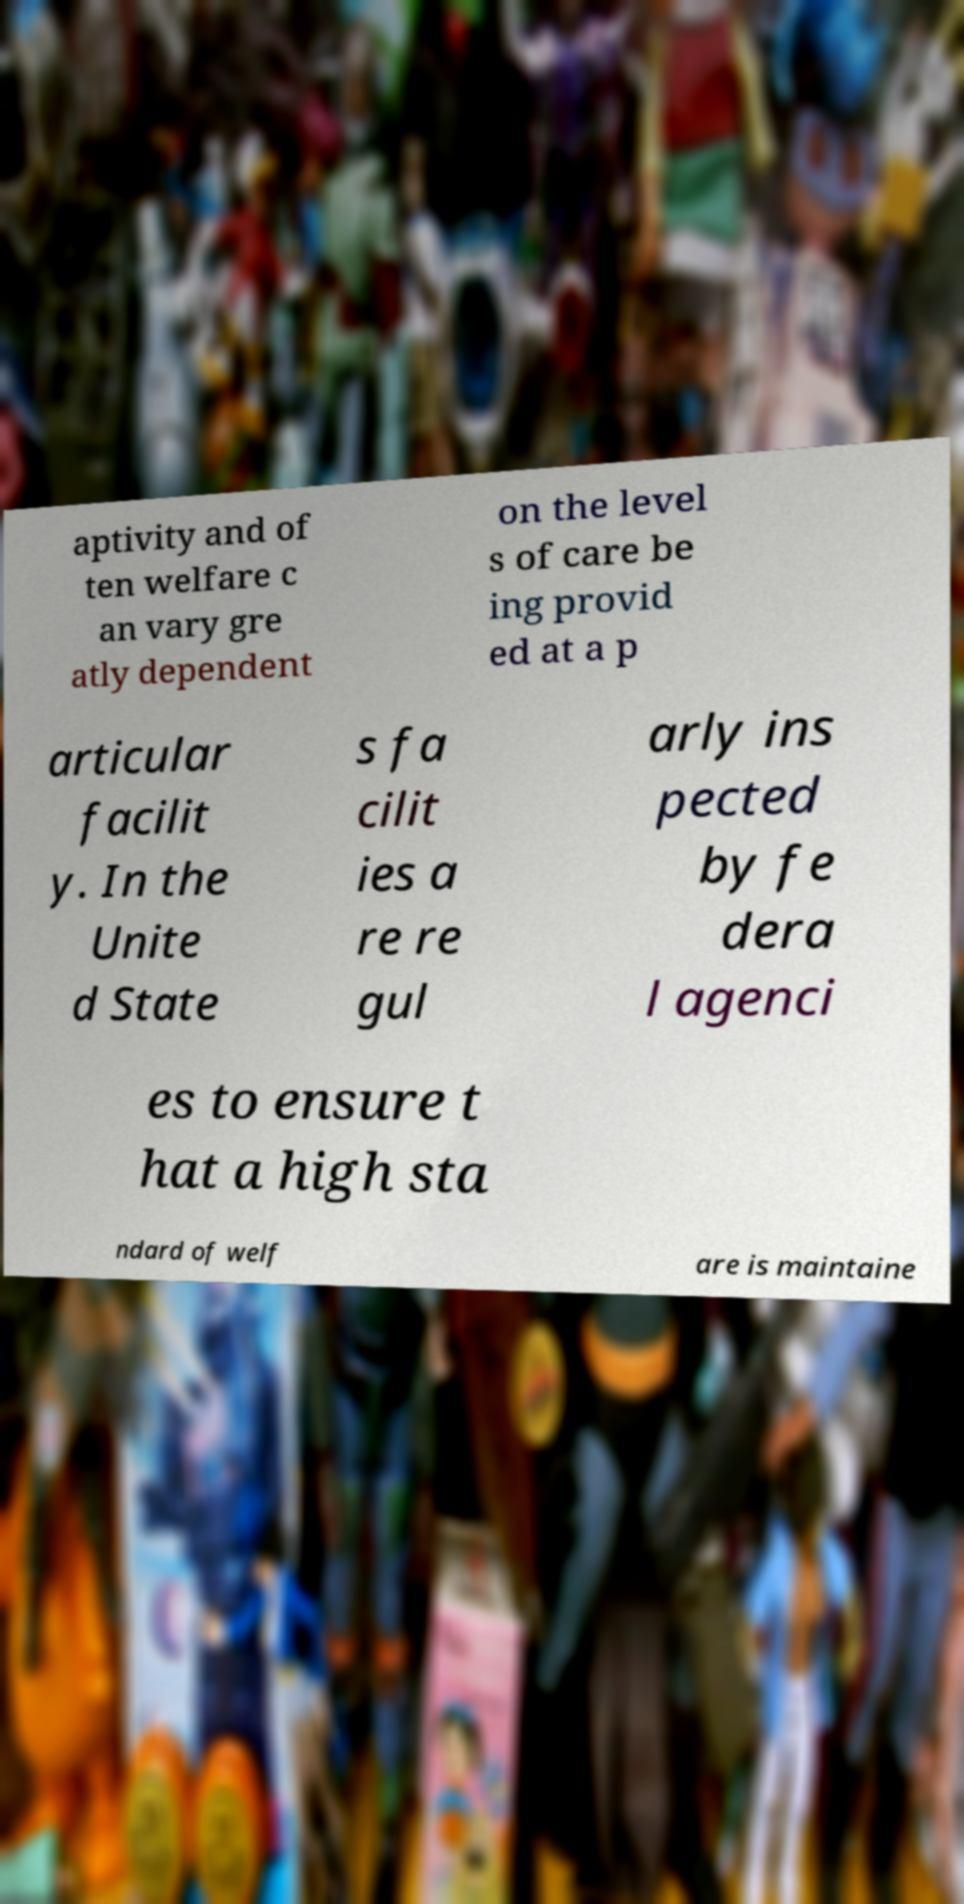For documentation purposes, I need the text within this image transcribed. Could you provide that? aptivity and of ten welfare c an vary gre atly dependent on the level s of care be ing provid ed at a p articular facilit y. In the Unite d State s fa cilit ies a re re gul arly ins pected by fe dera l agenci es to ensure t hat a high sta ndard of welf are is maintaine 